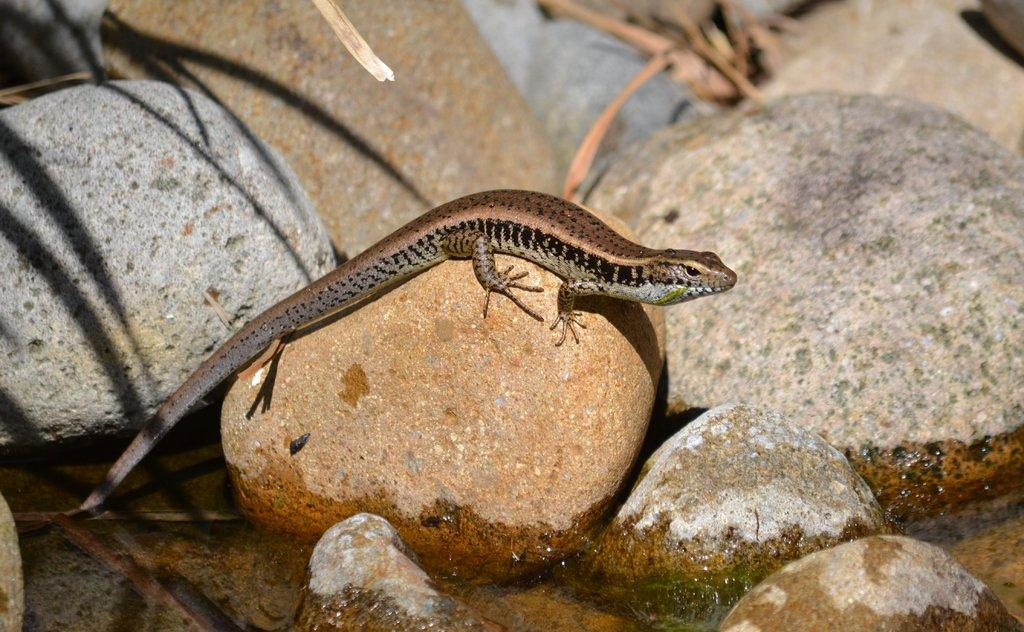What type of animal is in the image? There is a reptile in the image. What is the reptile in contact with in the image? The reptile is in contact with water in the image. What other natural elements are present in the image? Rocks and leaves are visible in the image. What educational institution does the reptile attend in the image? There is no indication in the image that the reptile attends any educational institution. 